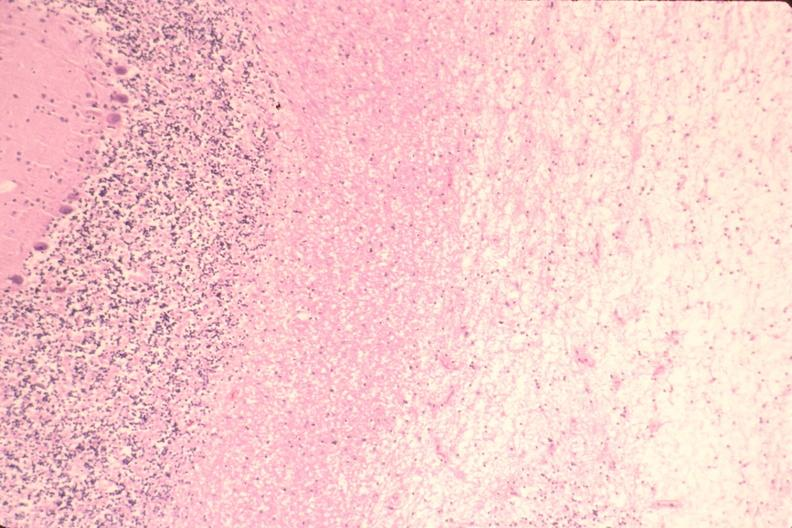what does this image show?
Answer the question using a single word or phrase. Brain 